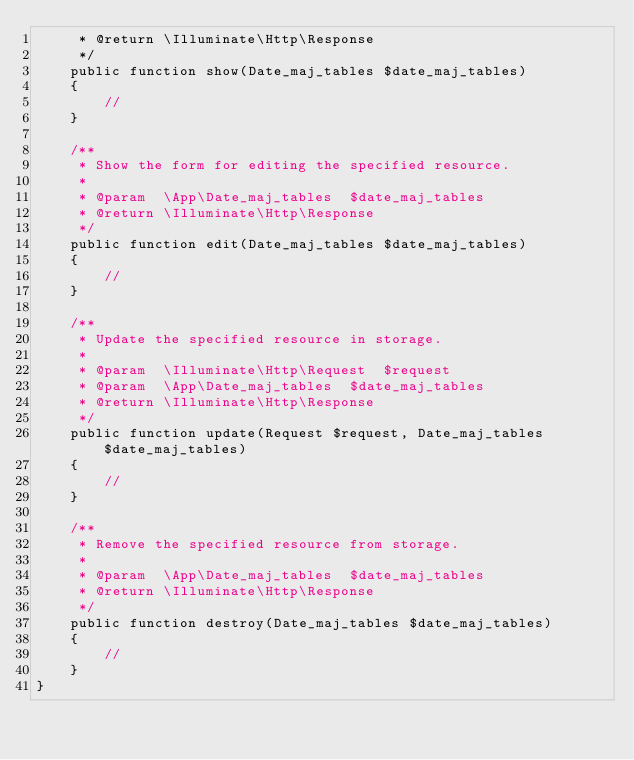Convert code to text. <code><loc_0><loc_0><loc_500><loc_500><_PHP_>     * @return \Illuminate\Http\Response
     */
    public function show(Date_maj_tables $date_maj_tables)
    {
        //
    }

    /**
     * Show the form for editing the specified resource.
     *
     * @param  \App\Date_maj_tables  $date_maj_tables
     * @return \Illuminate\Http\Response
     */
    public function edit(Date_maj_tables $date_maj_tables)
    {
        //
    }

    /**
     * Update the specified resource in storage.
     *
     * @param  \Illuminate\Http\Request  $request
     * @param  \App\Date_maj_tables  $date_maj_tables
     * @return \Illuminate\Http\Response
     */
    public function update(Request $request, Date_maj_tables $date_maj_tables)
    {
        //
    }

    /**
     * Remove the specified resource from storage.
     *
     * @param  \App\Date_maj_tables  $date_maj_tables
     * @return \Illuminate\Http\Response
     */
    public function destroy(Date_maj_tables $date_maj_tables)
    {
        //
    }
}
</code> 